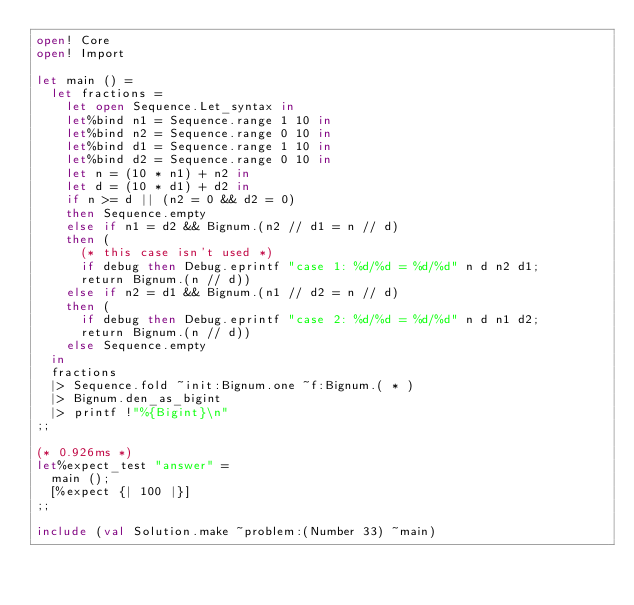<code> <loc_0><loc_0><loc_500><loc_500><_OCaml_>open! Core
open! Import

let main () =
  let fractions =
    let open Sequence.Let_syntax in
    let%bind n1 = Sequence.range 1 10 in
    let%bind n2 = Sequence.range 0 10 in
    let%bind d1 = Sequence.range 1 10 in
    let%bind d2 = Sequence.range 0 10 in
    let n = (10 * n1) + n2 in
    let d = (10 * d1) + d2 in
    if n >= d || (n2 = 0 && d2 = 0)
    then Sequence.empty
    else if n1 = d2 && Bignum.(n2 // d1 = n // d)
    then (
      (* this case isn't used *)
      if debug then Debug.eprintf "case 1: %d/%d = %d/%d" n d n2 d1;
      return Bignum.(n // d))
    else if n2 = d1 && Bignum.(n1 // d2 = n // d)
    then (
      if debug then Debug.eprintf "case 2: %d/%d = %d/%d" n d n1 d2;
      return Bignum.(n // d))
    else Sequence.empty
  in
  fractions
  |> Sequence.fold ~init:Bignum.one ~f:Bignum.( * )
  |> Bignum.den_as_bigint
  |> printf !"%{Bigint}\n"
;;

(* 0.926ms *)
let%expect_test "answer" =
  main ();
  [%expect {| 100 |}]
;;

include (val Solution.make ~problem:(Number 33) ~main)
</code> 